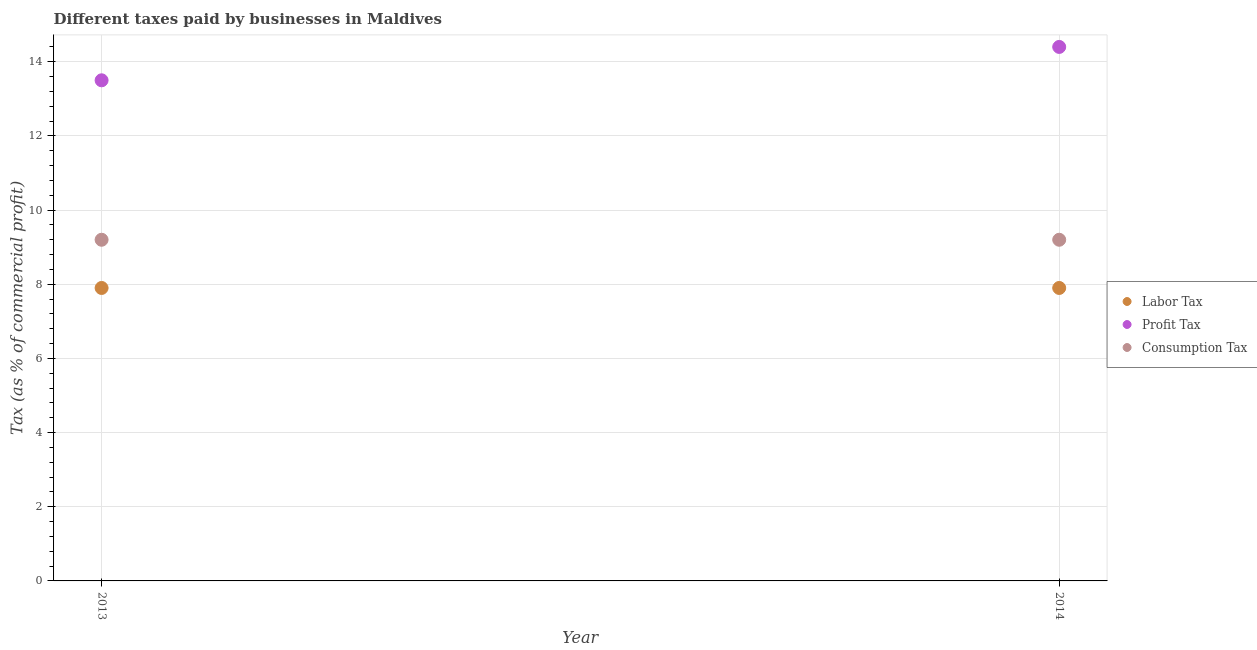How many different coloured dotlines are there?
Your answer should be compact. 3. What is the percentage of profit tax in 2013?
Your response must be concise. 13.5. In which year was the percentage of consumption tax maximum?
Ensure brevity in your answer.  2013. In which year was the percentage of profit tax minimum?
Your answer should be very brief. 2013. What is the total percentage of consumption tax in the graph?
Your answer should be compact. 18.4. What is the difference between the percentage of consumption tax in 2013 and that in 2014?
Your answer should be very brief. 0. What is the difference between the percentage of consumption tax in 2014 and the percentage of profit tax in 2013?
Make the answer very short. -4.3. What is the average percentage of profit tax per year?
Provide a short and direct response. 13.95. In the year 2013, what is the difference between the percentage of labor tax and percentage of consumption tax?
Provide a succinct answer. -1.3. What is the ratio of the percentage of labor tax in 2013 to that in 2014?
Provide a succinct answer. 1. In how many years, is the percentage of labor tax greater than the average percentage of labor tax taken over all years?
Provide a succinct answer. 0. Is it the case that in every year, the sum of the percentage of labor tax and percentage of profit tax is greater than the percentage of consumption tax?
Offer a terse response. Yes. Does the percentage of labor tax monotonically increase over the years?
Your answer should be very brief. No. Is the percentage of profit tax strictly greater than the percentage of consumption tax over the years?
Provide a succinct answer. Yes. Is the percentage of consumption tax strictly less than the percentage of labor tax over the years?
Make the answer very short. No. How many years are there in the graph?
Provide a short and direct response. 2. What is the difference between two consecutive major ticks on the Y-axis?
Offer a very short reply. 2. Where does the legend appear in the graph?
Offer a very short reply. Center right. How many legend labels are there?
Your answer should be very brief. 3. How are the legend labels stacked?
Keep it short and to the point. Vertical. What is the title of the graph?
Keep it short and to the point. Different taxes paid by businesses in Maldives. Does "Labor Tax" appear as one of the legend labels in the graph?
Provide a succinct answer. Yes. What is the label or title of the X-axis?
Offer a terse response. Year. What is the label or title of the Y-axis?
Make the answer very short. Tax (as % of commercial profit). What is the Tax (as % of commercial profit) in Labor Tax in 2013?
Offer a very short reply. 7.9. What is the Tax (as % of commercial profit) in Consumption Tax in 2013?
Keep it short and to the point. 9.2. Across all years, what is the maximum Tax (as % of commercial profit) of Profit Tax?
Your response must be concise. 14.4. Across all years, what is the maximum Tax (as % of commercial profit) of Consumption Tax?
Offer a terse response. 9.2. Across all years, what is the minimum Tax (as % of commercial profit) of Labor Tax?
Offer a terse response. 7.9. Across all years, what is the minimum Tax (as % of commercial profit) of Profit Tax?
Keep it short and to the point. 13.5. What is the total Tax (as % of commercial profit) of Profit Tax in the graph?
Provide a succinct answer. 27.9. What is the difference between the Tax (as % of commercial profit) of Labor Tax in 2013 and that in 2014?
Offer a terse response. 0. What is the difference between the Tax (as % of commercial profit) in Profit Tax in 2013 and that in 2014?
Keep it short and to the point. -0.9. What is the difference between the Tax (as % of commercial profit) in Consumption Tax in 2013 and that in 2014?
Offer a very short reply. 0. What is the difference between the Tax (as % of commercial profit) in Labor Tax in 2013 and the Tax (as % of commercial profit) in Profit Tax in 2014?
Your answer should be very brief. -6.5. What is the difference between the Tax (as % of commercial profit) of Profit Tax in 2013 and the Tax (as % of commercial profit) of Consumption Tax in 2014?
Your response must be concise. 4.3. What is the average Tax (as % of commercial profit) of Labor Tax per year?
Make the answer very short. 7.9. What is the average Tax (as % of commercial profit) in Profit Tax per year?
Provide a short and direct response. 13.95. In the year 2013, what is the difference between the Tax (as % of commercial profit) in Labor Tax and Tax (as % of commercial profit) in Profit Tax?
Give a very brief answer. -5.6. In the year 2013, what is the difference between the Tax (as % of commercial profit) of Profit Tax and Tax (as % of commercial profit) of Consumption Tax?
Your response must be concise. 4.3. In the year 2014, what is the difference between the Tax (as % of commercial profit) in Labor Tax and Tax (as % of commercial profit) in Consumption Tax?
Your answer should be very brief. -1.3. What is the ratio of the Tax (as % of commercial profit) of Consumption Tax in 2013 to that in 2014?
Give a very brief answer. 1. What is the difference between the highest and the second highest Tax (as % of commercial profit) of Labor Tax?
Provide a short and direct response. 0. What is the difference between the highest and the second highest Tax (as % of commercial profit) of Consumption Tax?
Make the answer very short. 0. What is the difference between the highest and the lowest Tax (as % of commercial profit) of Profit Tax?
Your answer should be very brief. 0.9. 